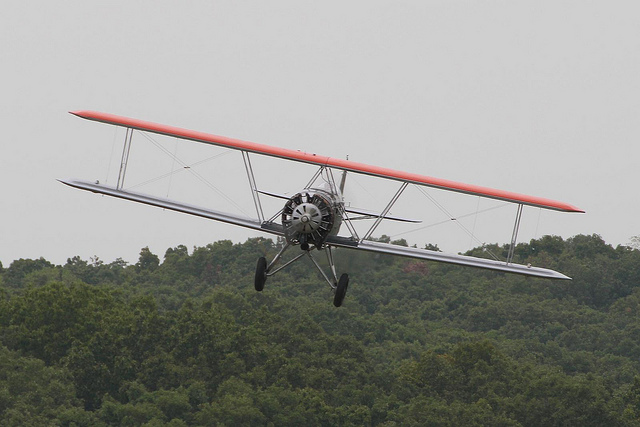Can you tell me the possible era or time period this biplane might be from? Based on the aircraft design, which includes features like the stacked wings, open cockpit, and the radial engine, it appears to be a biplane from the early 20th century. This style was prominent from around 1910 through the 1930s, especially during World War I. 